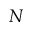Convert formula to latex. <formula><loc_0><loc_0><loc_500><loc_500>N</formula> 